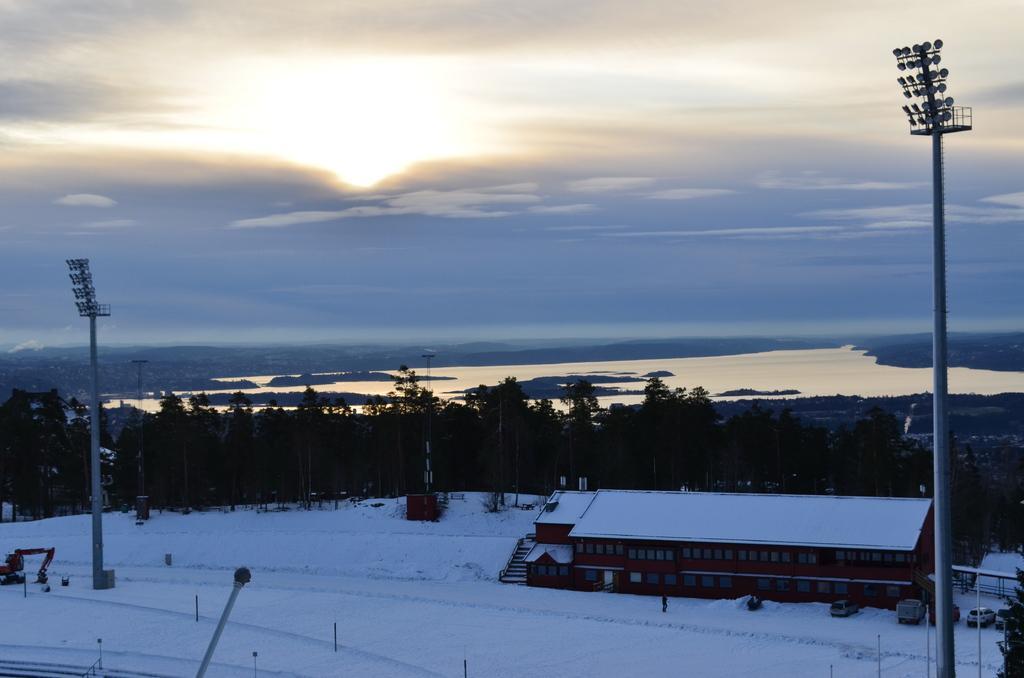How would you summarize this image in a sentence or two? In this picture we can see a house with windows, vehicles, snow, poles, lights, trees and in the background we can see the sky. 